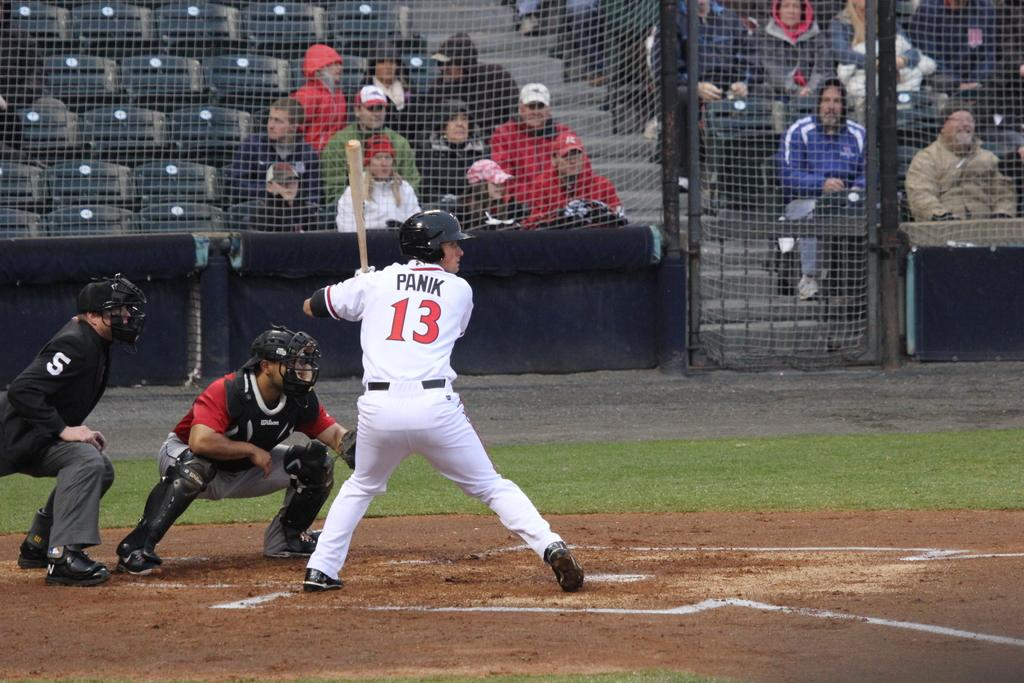<image>
Give a short and clear explanation of the subsequent image. Player 13, named Panik is up at bat. 